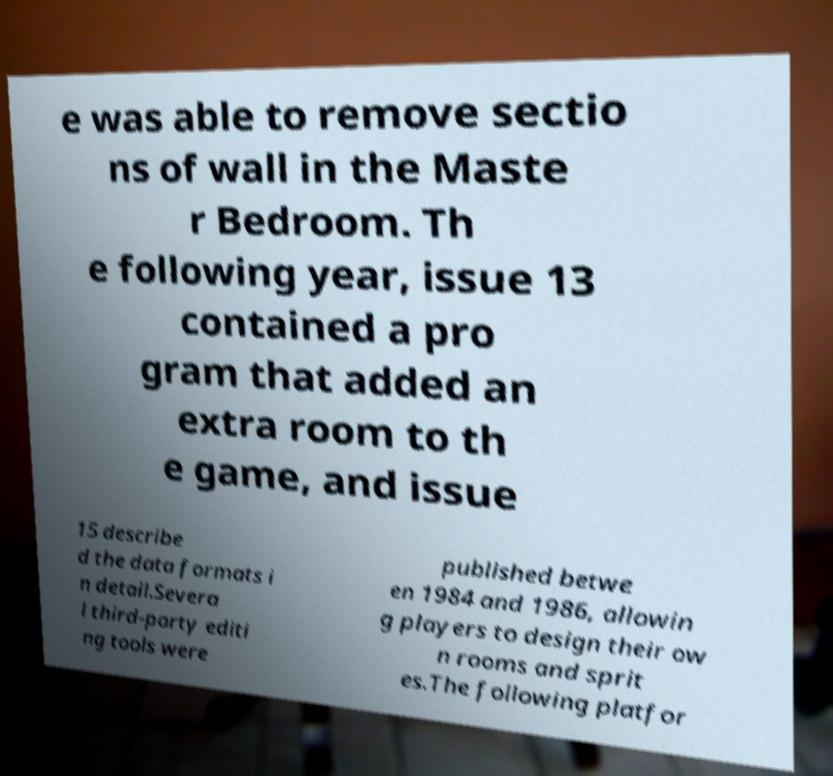For documentation purposes, I need the text within this image transcribed. Could you provide that? e was able to remove sectio ns of wall in the Maste r Bedroom. Th e following year, issue 13 contained a pro gram that added an extra room to th e game, and issue 15 describe d the data formats i n detail.Severa l third-party editi ng tools were published betwe en 1984 and 1986, allowin g players to design their ow n rooms and sprit es.The following platfor 